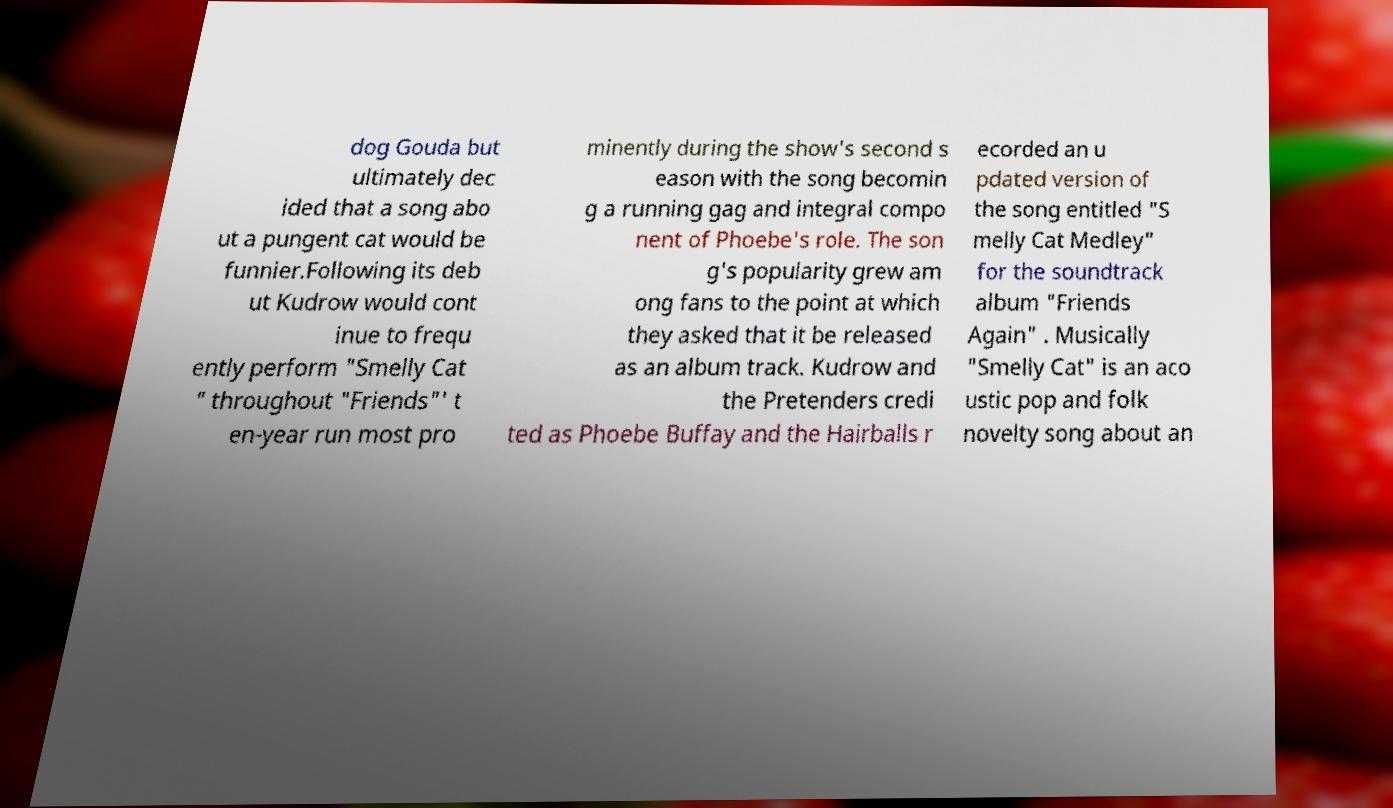What messages or text are displayed in this image? I need them in a readable, typed format. dog Gouda but ultimately dec ided that a song abo ut a pungent cat would be funnier.Following its deb ut Kudrow would cont inue to frequ ently perform "Smelly Cat " throughout "Friends"' t en-year run most pro minently during the show's second s eason with the song becomin g a running gag and integral compo nent of Phoebe's role. The son g's popularity grew am ong fans to the point at which they asked that it be released as an album track. Kudrow and the Pretenders credi ted as Phoebe Buffay and the Hairballs r ecorded an u pdated version of the song entitled "S melly Cat Medley" for the soundtrack album "Friends Again" . Musically "Smelly Cat" is an aco ustic pop and folk novelty song about an 